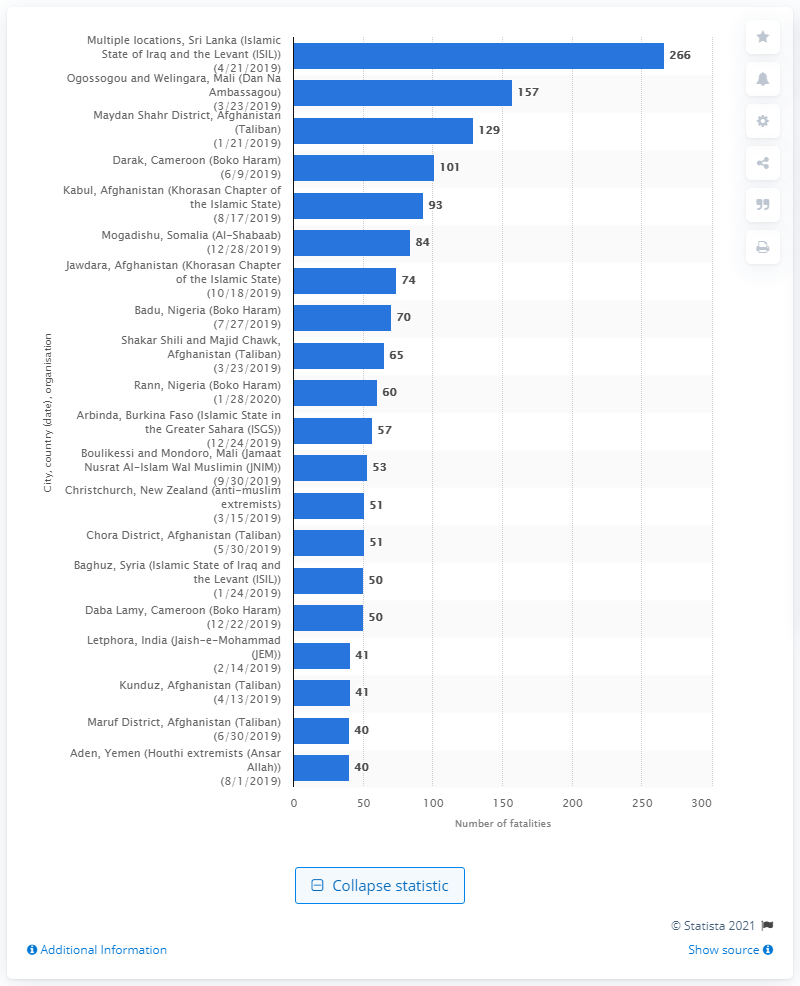Draw attention to some important aspects in this diagram. According to official reports, 266 people lost their lives in the ISIL attacks. 